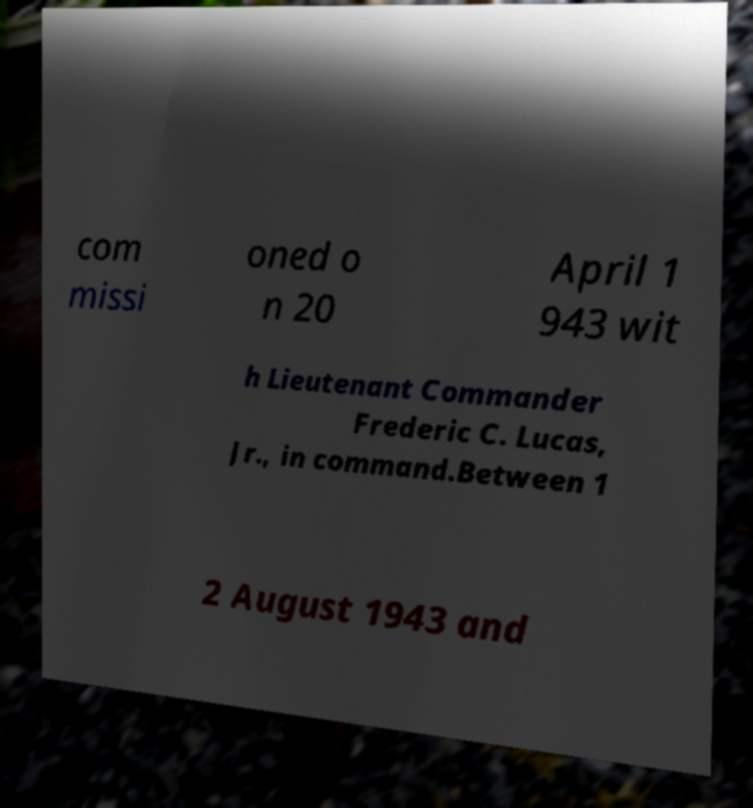Can you read and provide the text displayed in the image?This photo seems to have some interesting text. Can you extract and type it out for me? com missi oned o n 20 April 1 943 wit h Lieutenant Commander Frederic C. Lucas, Jr., in command.Between 1 2 August 1943 and 